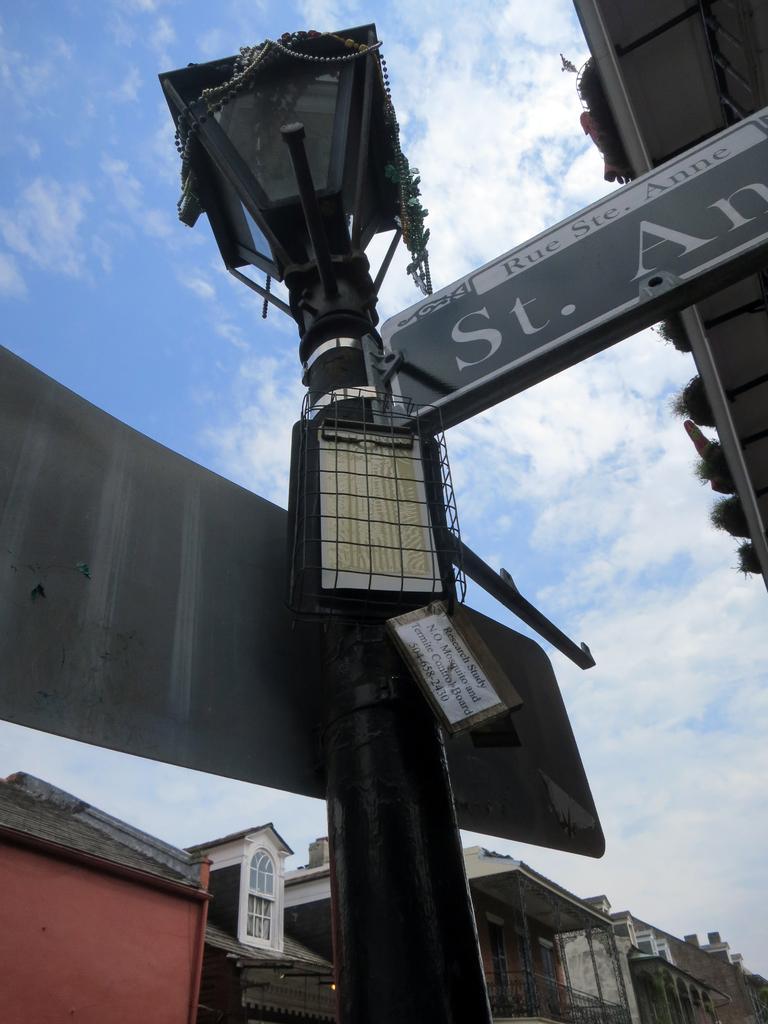Describe this image in one or two sentences. In this picture we can see a pole with directional boards and a light. Behind the board there are buildings and a sky. 